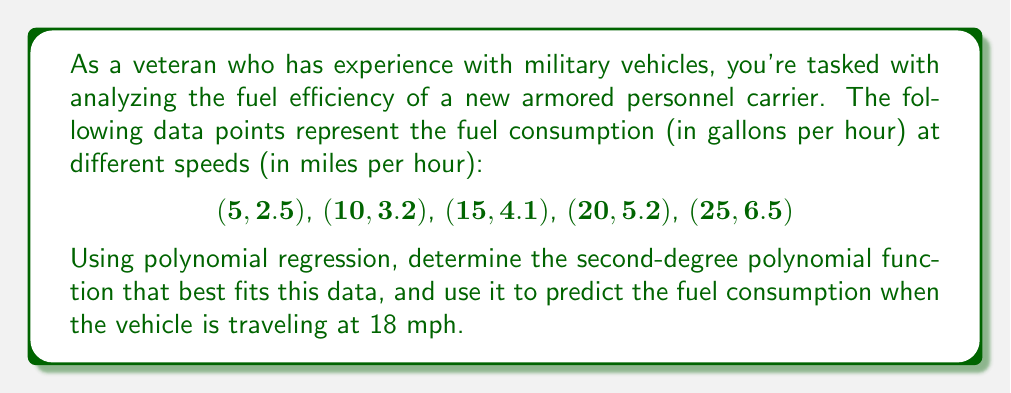Can you answer this question? To solve this problem, we'll use second-degree polynomial regression to find a function of the form $f(x) = ax^2 + bx + c$ that best fits the given data points.

Step 1: Set up the system of normal equations:
$$\begin{cases}
\sum x^4 a + \sum x^3 b + \sum x^2 c = \sum x^2 y \\
\sum x^3 a + \sum x^2 b + \sum x c = \sum x y \\
\sum x^2 a + \sum x b + n c = \sum y
\end{cases}$$

Step 2: Calculate the sums:
$\sum x^4 = 5^4 + 10^4 + 15^4 + 20^4 + 25^4 = 290,625$
$\sum x^3 = 5^3 + 10^3 + 15^3 + 20^3 + 25^3 = 39,375$
$\sum x^2 = 5^2 + 10^2 + 15^2 + 20^2 + 25^2 = 1,875$
$\sum x = 5 + 10 + 15 + 20 + 25 = 75$
$n = 5$
$\sum y = 2.5 + 3.2 + 4.1 + 5.2 + 6.5 = 21.5$
$\sum x^2 y = 5^2(2.5) + 10^2(3.2) + 15^2(4.1) + 20^2(5.2) + 25^2(6.5) = 10,912.5$
$\sum xy = 5(2.5) + 10(3.2) + 15(4.1) + 20(5.2) + 25(6.5) = 447.5$

Step 3: Substitute these values into the system of equations:
$$\begin{cases}
290,625a + 39,375b + 1,875c = 10,912.5 \\
39,375a + 1,875b + 75c = 447.5 \\
1,875a + 75b + 5c = 21.5
\end{cases}$$

Step 4: Solve this system of equations (using a calculator or computer algebra system) to get:
$a \approx 0.0040$
$b \approx 0.1360$
$c \approx 2.0600$

Step 5: Write the polynomial function:
$f(x) \approx 0.0040x^2 + 0.1360x + 2.0600$

Step 6: Predict the fuel consumption at 18 mph by evaluating $f(18)$:
$f(18) \approx 0.0040(18)^2 + 0.1360(18) + 2.0600$
$f(18) \approx 1.2960 + 2.4480 + 2.0600$
$f(18) \approx 4.8040$

Therefore, the predicted fuel consumption when the vehicle is traveling at 18 mph is approximately 4.804 gallons per hour.
Answer: 4.804 gallons per hour 